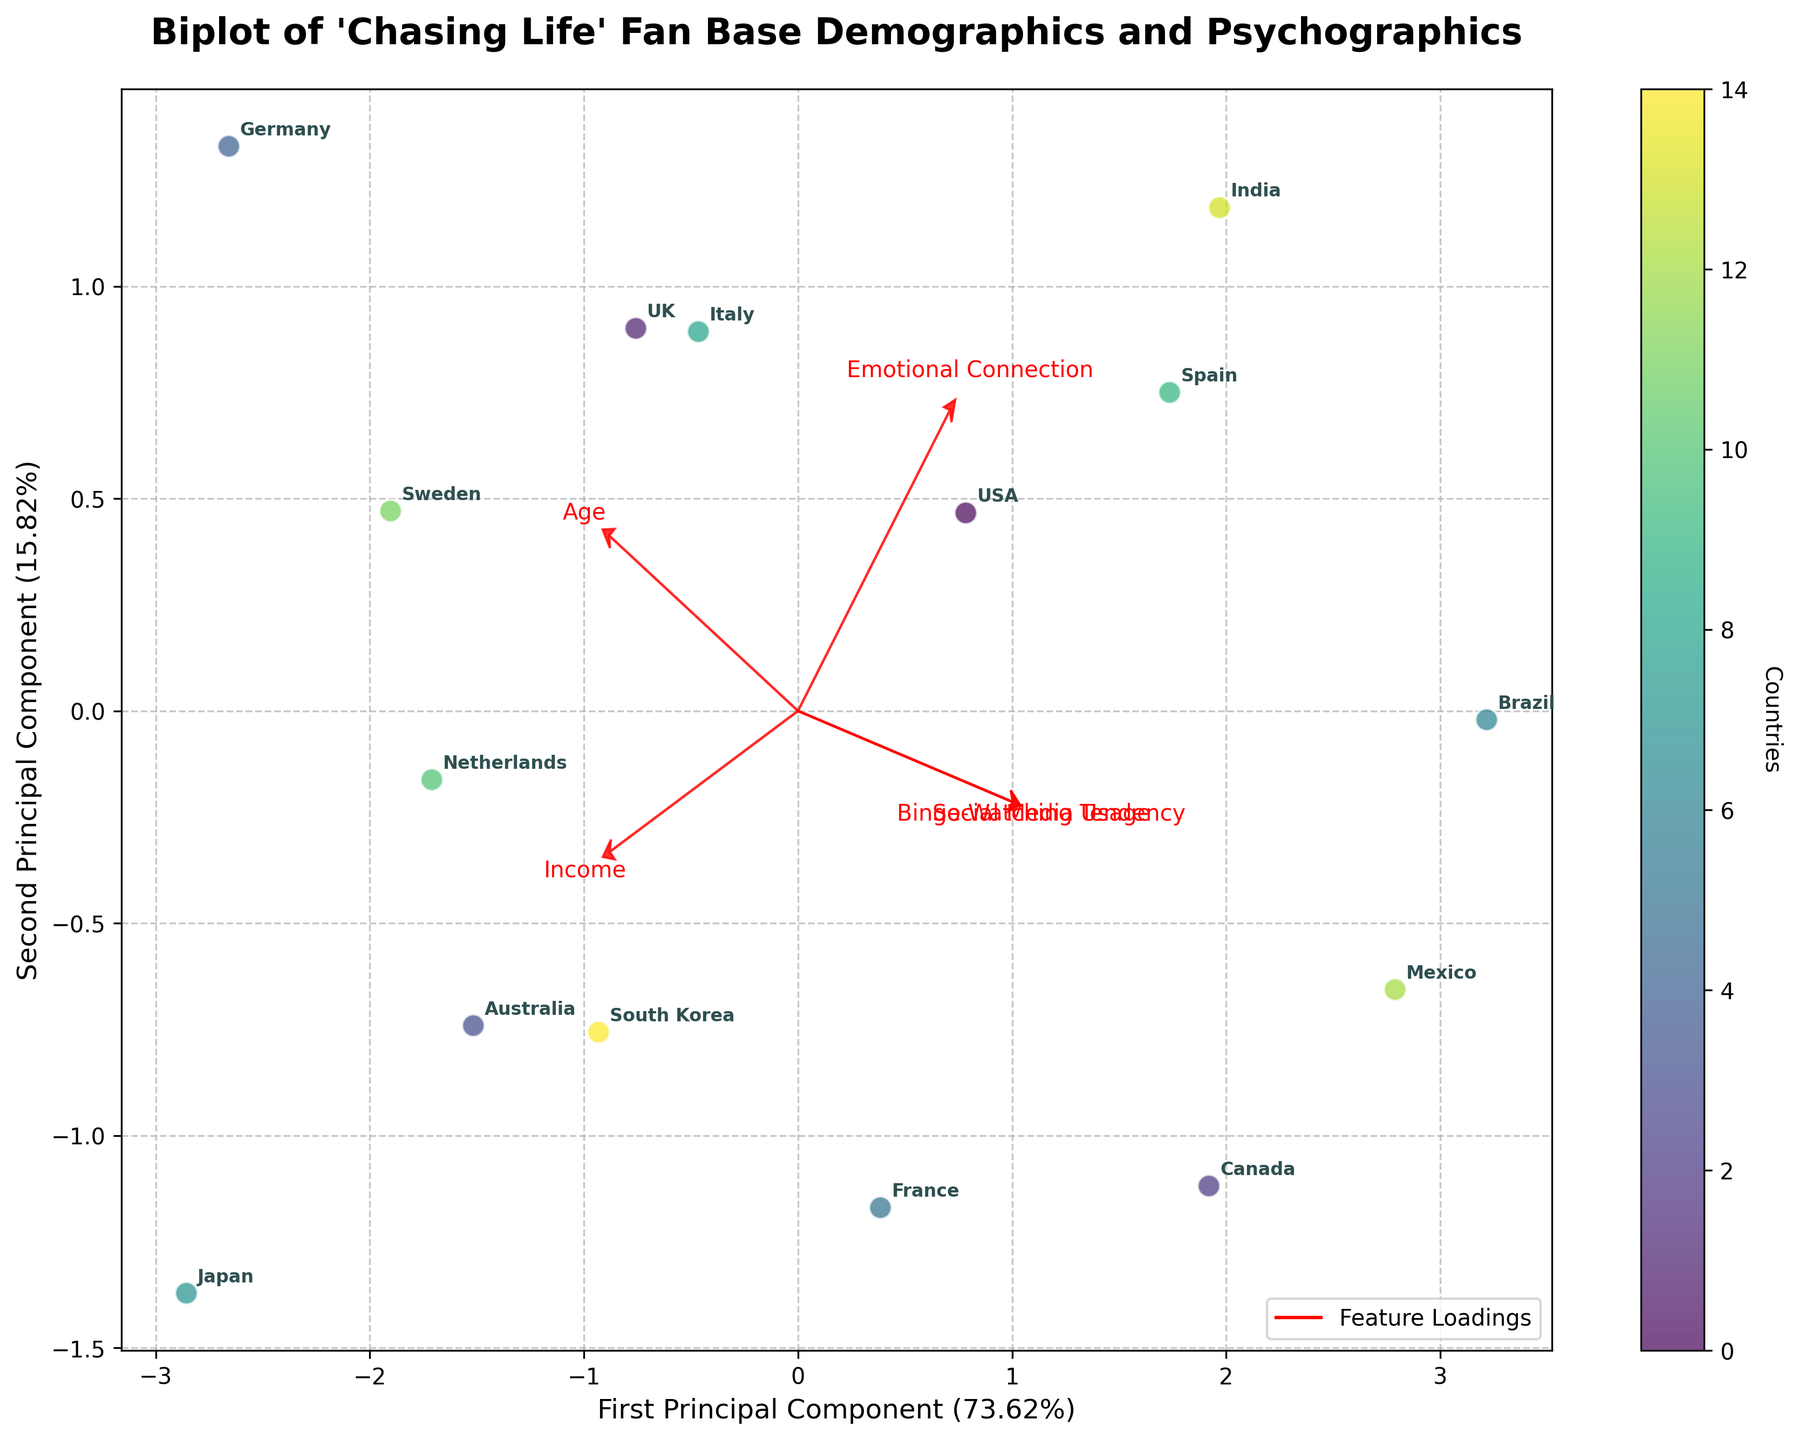How many countries are represented in the biplot? The biplot includes data points, each representing a different country. By counting the data points, we can determine the number of countries. The scatter plot has data points with country labels next to each point. Counting these labels gives us the total number of countries.
Answer: 15 Which country has the highest "Emotional Connection" score, and what is its position in principal component space? To find the country with the highest "Emotional Connection" score, we can look at the feature loading vector for "Emotional Connection" and find which data point (country) is closest to the direction of this arrow. The country that is furthest along this loading vector positively will have the highest score. Comparing their positions, Brazil and Spain are near the "Emotional Connection" vector. Checking the coordinate positions and annotations, the countries at the extreme point closest to this vector are Brazil and Spain.
Answer: Brazil and Spain What is the relationship between "Social Media Usage" and "Binge-Watching Tendency"? The relationship between "Social Media Usage" and "Binge-Watching Tendency" can be analyzed by examining the angles between their loading vectors. Vectors close together indicate a positive correlation. The arrow vectors for these two features point in similar directions, suggesting they are positively correlated. This means countries with high "Social Media Usage" tend to have high "Binge-Watching Tendency."
Answer: Positive correlation Which principal component accounts for more variance in the data, and by how much? We need to compare the explained variance ratios of the first and second principal components. These ratios are usually displayed on the axes labels. The figure legend shows the explained variance for PC1 and PC2 as percentages in parentheses. Referring to these labels: the First Principal Component accounts for more variance. For instance, if PC1 accounts for 40% and PC2 for 30%, PC1 accounts for 10% more variance than PC2. Reading more specific data values:
Answer: First Principal Component; the exact amount of variance can be directly taken from explanations percentage values Which two countries are most similar in terms of their demographics and psychographics? The most similar countries will have their data points closest to each other in the PCA-transformed space. Looking at the scatter plot, identify pairs of countries that are neighbors or very near each other. Comparative proximity helps us infer similarity in their demographic and psychographic profiles. Examples could be South Korea and USA, or Sweden and Germany; check the closest-neighbor data points in the plot and their annotations.
Answer: South Korea and USA 